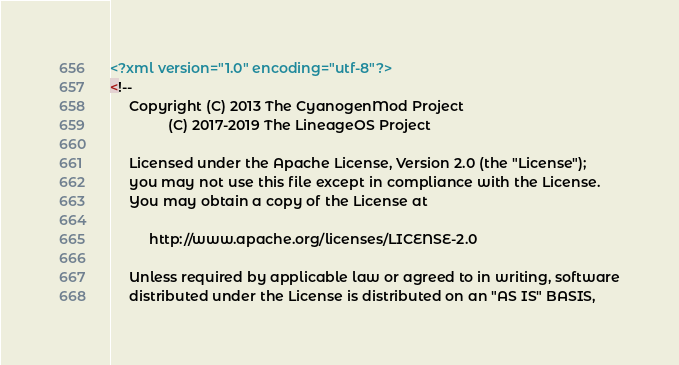Convert code to text. <code><loc_0><loc_0><loc_500><loc_500><_XML_><?xml version="1.0" encoding="utf-8"?>
<!--
     Copyright (C) 2013 The CyanogenMod Project
               (C) 2017-2019 The LineageOS Project

     Licensed under the Apache License, Version 2.0 (the "License");
     you may not use this file except in compliance with the License.
     You may obtain a copy of the License at

          http://www.apache.org/licenses/LICENSE-2.0

     Unless required by applicable law or agreed to in writing, software
     distributed under the License is distributed on an "AS IS" BASIS,</code> 